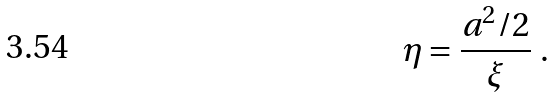Convert formula to latex. <formula><loc_0><loc_0><loc_500><loc_500>\eta = { \frac { a ^ { 2 } / 2 } { \xi } } \ .</formula> 